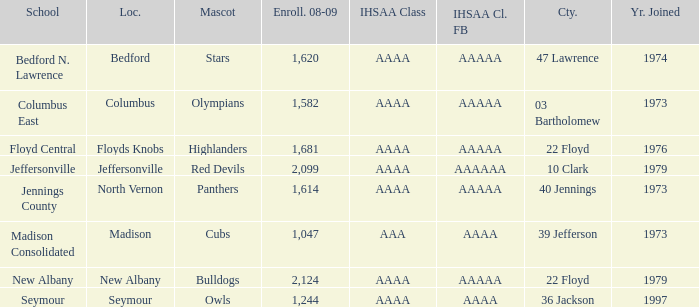What's the IHSAA Class when the school is Seymour? AAAA. 